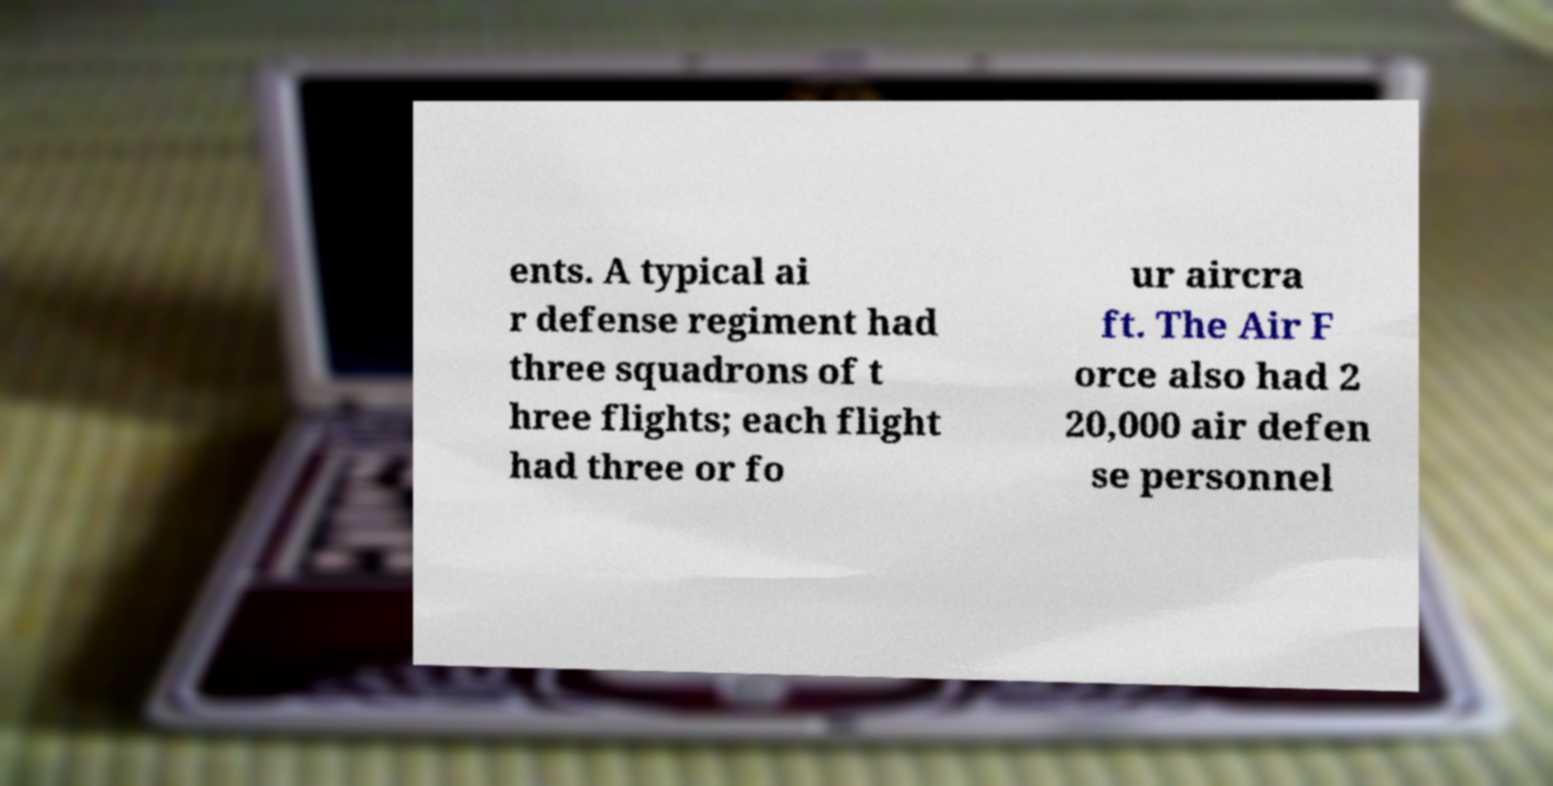Can you read and provide the text displayed in the image?This photo seems to have some interesting text. Can you extract and type it out for me? ents. A typical ai r defense regiment had three squadrons of t hree flights; each flight had three or fo ur aircra ft. The Air F orce also had 2 20,000 air defen se personnel 